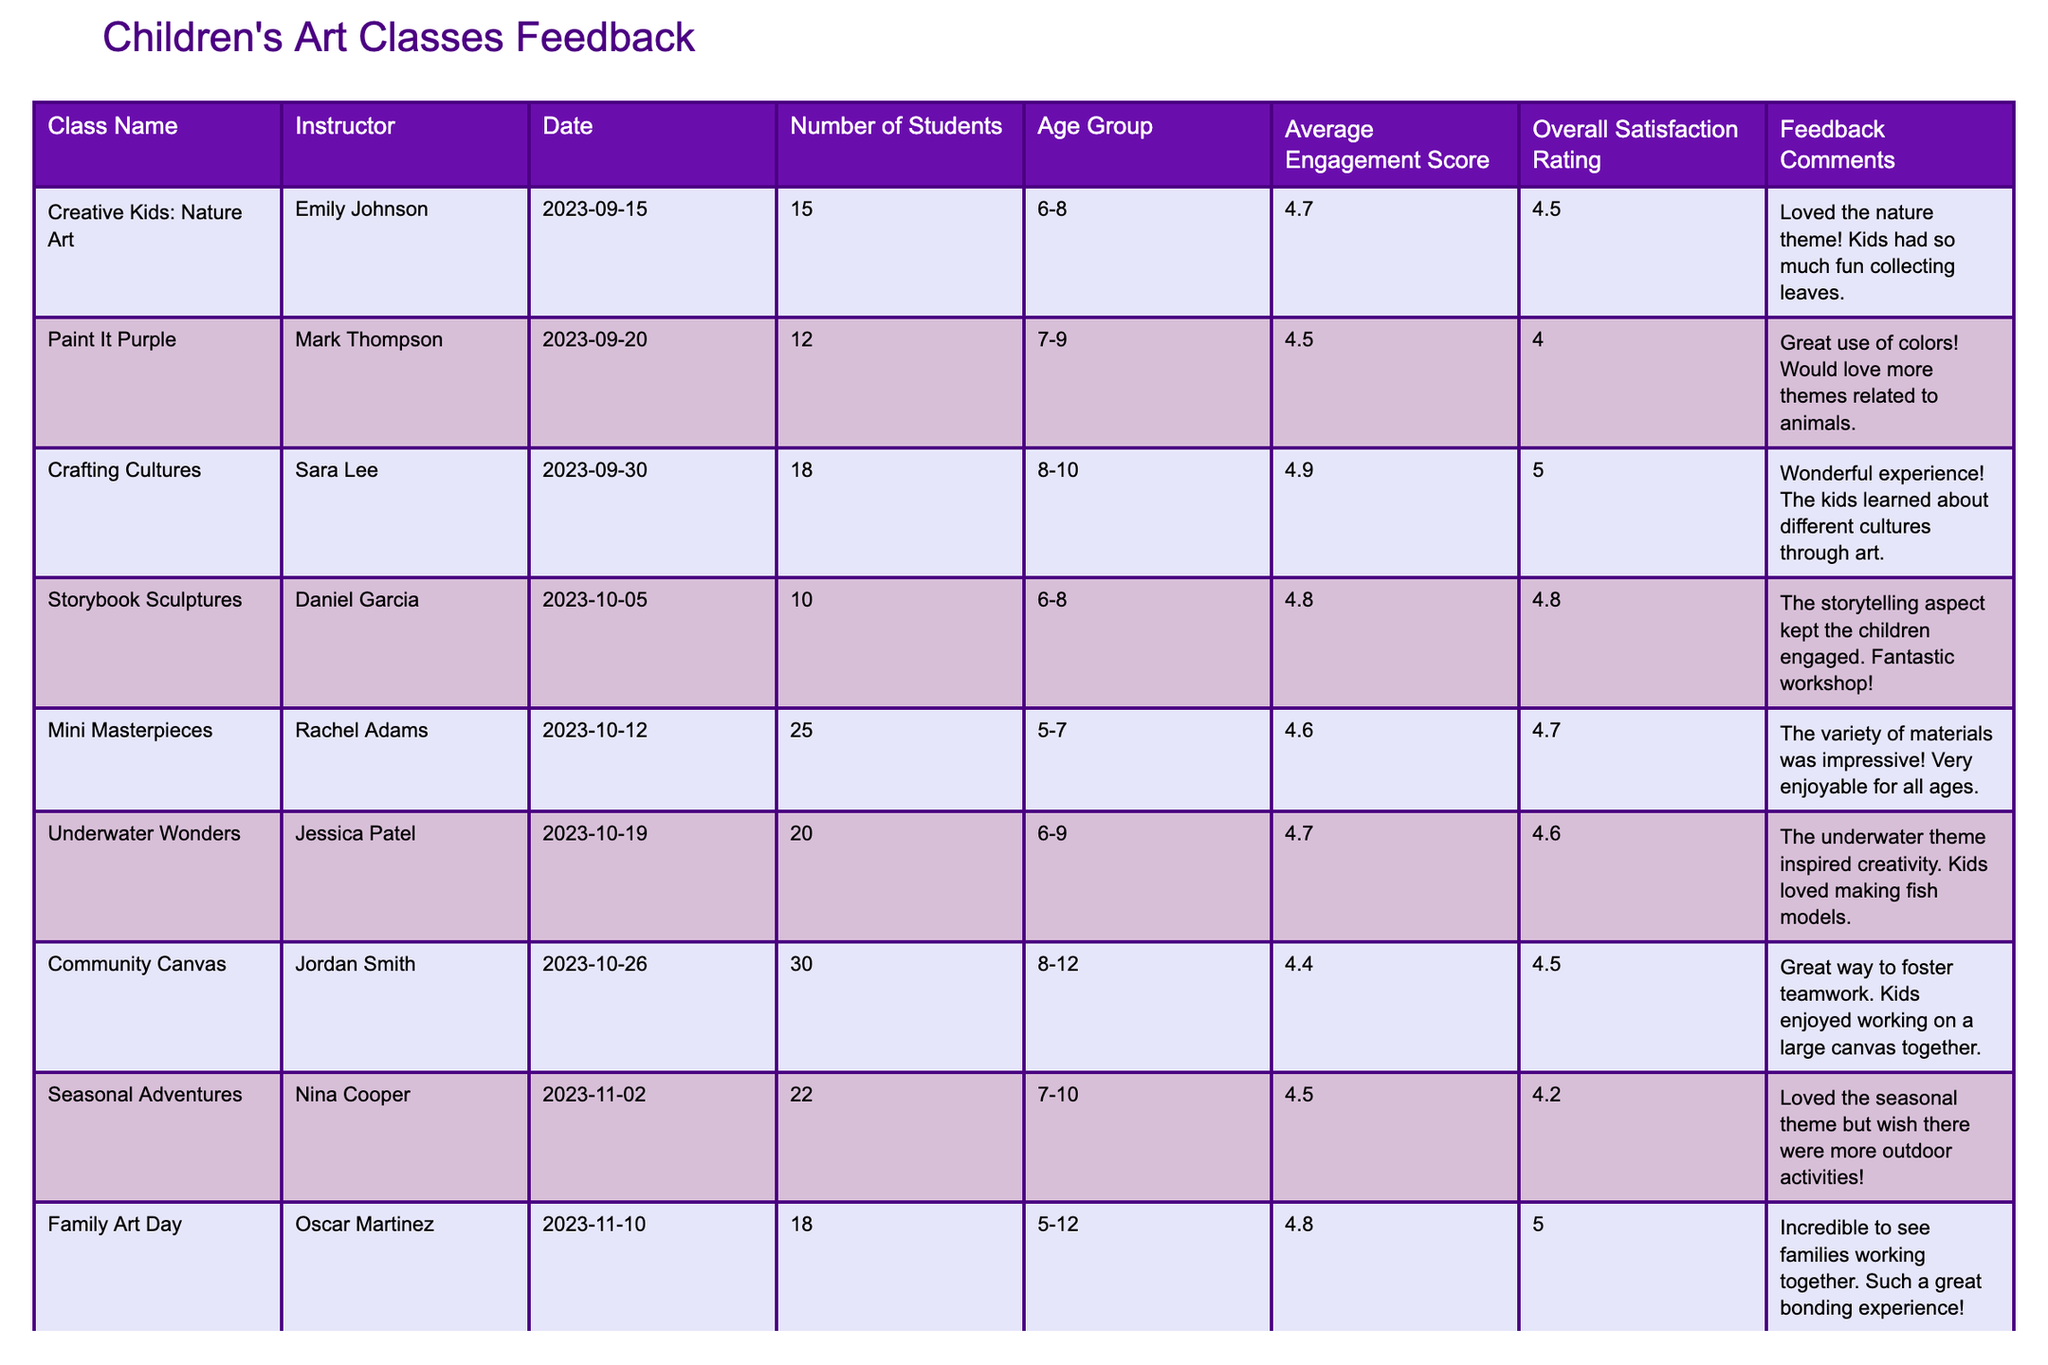What is the highest Overall Satisfaction Rating among the classes? By examining the Overall Satisfaction Rating column, the highest value is 5.0, which corresponds to the classes "Crafting Cultures" and "Family Art Day."
Answer: 5.0 Which class had the lowest Average Engagement Score? Looking through the Average Engagement Score column, "Community Canvas" has the lowest score of 4.4.
Answer: 4.4 How many students participated in the "Underwater Wonders" class? The Number of Students column indicates that "Underwater Wonders" had 20 students.
Answer: 20 What is the average engagement score for the classes targeted at the age group 6-8? The classes targeting age group 6-8 are "Creative Kids: Nature Art," "Storybook Sculptures," and "Underwater Wonders." Their engagement scores are 4.7, 4.8, and 4.7 respectively. Calculating the average: (4.7 + 4.8 + 4.7) / 3 = 4.7333, rounded to 4.7.
Answer: 4.7 Does the "Crafting Cultures" class have a higher satisfaction rating than the "Mini Masterpieces" class? "Crafting Cultures" has a satisfaction rating of 5.0, while "Mini Masterpieces" has a rating of 4.7. Therefore, it does have a higher rating.
Answer: Yes What is the total number of students across all the classes? To find the total, we sum the Number of Students for each class: 15 + 12 + 18 + 10 + 25 + 20 + 30 + 22 + 18 + 14 =  15 + 12 + 18 + 10 + 25 + 20 + 30 + 22 + 18 + 14 =  15 + 12 = 27 + 18 = 45 + 10 = 55 + 25 = 80 + 20 = 100 + 30 = 130 + 22 = 152 + 18 = 170 + 14 = 184.
Answer: 184 Which class received feedback about using more animal themes? The feedback comment for "Paint It Purple" mentions a desire for more themes related to animals.
Answer: "Paint It Purple" How does the average engagement score for age group 8-10 compare to that of age group 5-7? The average engagement score for age group 8-10 includes "Crafting Cultures" (4.9), "Community Canvas" (4.4), and "Seasonal Adventures" (4.5), totaling (4.9 + 4.4 + 4.5) / 3 = 4.53. For age group 5-7, there's "Mini Masterpieces" (4.6) and "Family Art Day” (4.8), totaling (4.6 + 4.8) / 2 = 4.7. 4.53 is lower than 4.7.
Answer: The age group 5-7 has a higher average score What percentage of the total number of students were in the "Family Art Day" class? The "Family Art Day" class had 18 students. To find the percentage: (18 / 184) * 100 = 9.78%.
Answer: Approximately 9.78% 